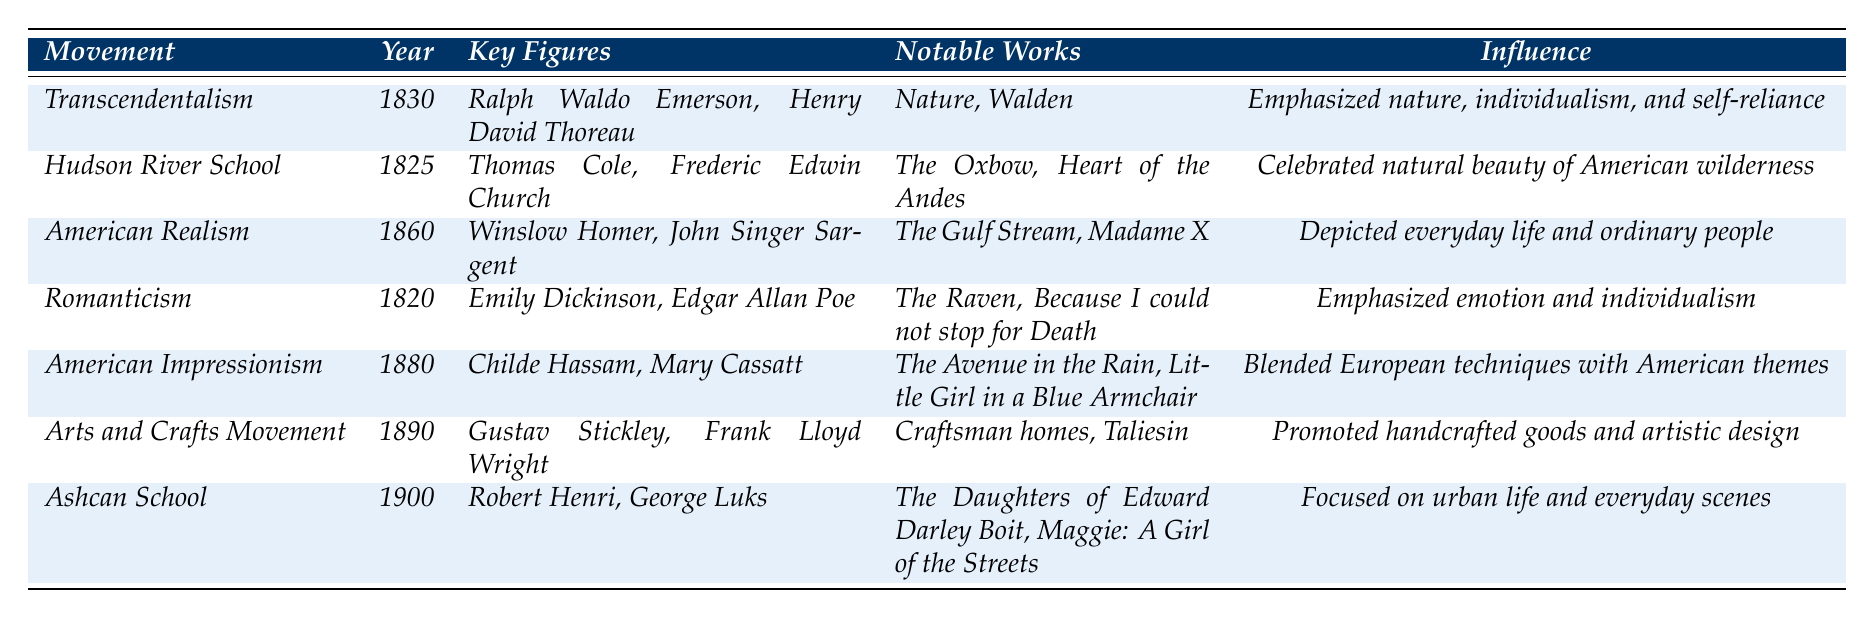What year did Transcendentalism emerge? According to the table, Transcendentalism is listed under the "Movement" column and has the year 1830 associated with it.
Answer: 1830 Which art movement is associated with Ralph Waldo Emerson? Ralph Waldo Emerson is listed as a key figure under the Transcendentalism movement.
Answer: Transcendentalism How many notable works are there for the American Realism movement? Under the American Realism movement, there are two listed notable works: "The Gulf Stream" and "Madame X".
Answer: 2 What is the primary influence of the Hudson River School movement? The influence for the Hudson River School is described as focusing on celebrating the natural beauty of the American wilderness.
Answer: Celebrated natural beauty of American wilderness Which movement was characterized by a focus on everyday life? The American Realism movement is characterized by focusing on depicting everyday life and ordinary people with accuracy.
Answer: American Realism Is Edgar Allan Poe associated with the Ashcan School? Edgar Allan Poe is listed as a key figure in the Romanticism movement, not the Ashcan School.
Answer: No What were the notable works of the Arts and Crafts Movement? The "Notable Works" associated with the Arts and Crafts Movement include "Craftsman homes" and "Taliesin".
Answer: Craftsman homes, Taliesin Which movement came earliest, American Impressionism or Romanticism? The years indicate Romanticism emerged in 1820 and American Impressionism in 1880. Therefore, Romanticism came earlier.
Answer: Romanticism How many movements emphasized individualism? Transcendentalism and Romanticism both emphasized individualism, so there are two such movements in the table.
Answer: 2 List two key figures from the Ashcan School. The Ashcan School lists Robert Henri and George Luks as its key figures.
Answer: Robert Henri, George Luks What influence does the American Impressionism movement highlight? The influence of American Impressionism is described as blending European techniques with American themes, focusing on light and everyday settings.
Answer: Blended European techniques with American themes Which art movement occurred in 1900? The Ashcan School is listed as the movement that occurred in 1900.
Answer: Ashcan School Identify the notable works associated with the Transcendentalism movement. The notable works for Transcendentalism are "Nature" and "Walden."
Answer: Nature, Walden Was the Arts and Crafts Movement focused on mass-produced goods? The Arts and Crafts Movement promoted handcrafted goods, not mass-produced items, indicating a focus on artisanal creation instead.
Answer: No What was the focus of the Ashcan School? The focus of the Ashcan School was on urban life and everyday scenes, often depicting the struggles of the working class.
Answer: Urban life and everyday scenes Which movement emphasized emotion in its works? Romanticism is the movement that emphasized emotion and individualism, glorifying the past and nature as well.
Answer: Romanticism 